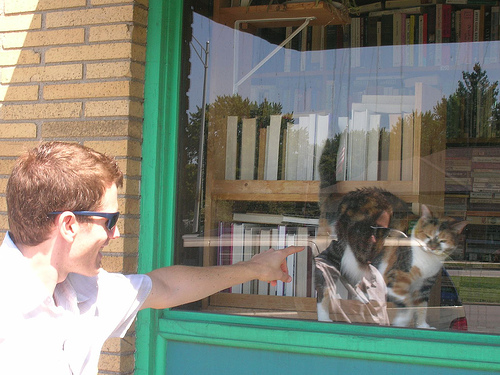<image>
Is there a cat on the shelf? Yes. Looking at the image, I can see the cat is positioned on top of the shelf, with the shelf providing support. Is there a cat next to the window? No. The cat is not positioned next to the window. They are located in different areas of the scene. Is the cat in front of the window? Yes. The cat is positioned in front of the window, appearing closer to the camera viewpoint. 